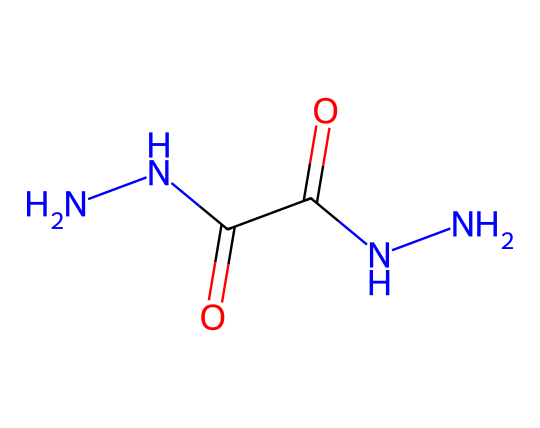What is the main functional group in this compound? The compound has carbonyl groups (C=O) indicated by the double bond to oxygen atoms. Carbonyl groups are characteristic of aldehydes and ketones. Since this molecule has two carbonyl groups, they are the main functional groups.
Answer: carbonyl How many nitrogen atoms are present in this molecule? By analyzing the chemical structure, there are two hydrazine groups (N-N) along with an additional nitrogen involved in the structure. Counting the nitrogen atoms gives a total of four.
Answer: four What type of reaction would hydrazines typically participate in? Hydrazines often act as reducing agents in chemical reactions, which means they donate electrons. Given their structure, they can reduce metallic ions to their elemental forms.
Answer: reduction Is this compound likely to be acidic or basic? The presence of nitrogen atoms in a hydrazine structure indicates its potential to donate protons, which makes it behave as a weak base rather than an acid due to its structure.
Answer: basic What is the total number of hydrogen atoms in this molecule? By analyzing the hydrazine functional groups and the structure containing carbonyls, we find that the molecule has a total of eight hydrogen atoms.
Answer: eight 